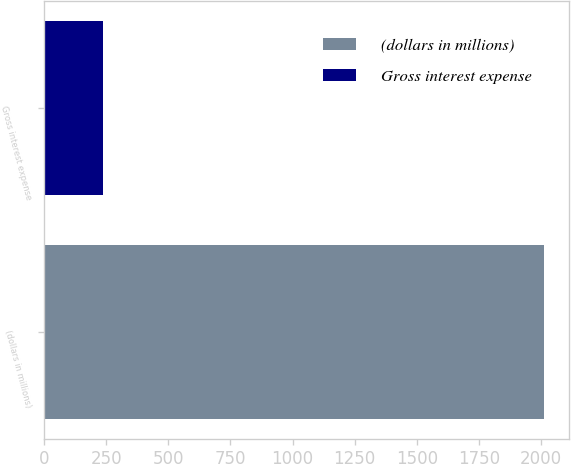Convert chart. <chart><loc_0><loc_0><loc_500><loc_500><bar_chart><fcel>(dollars in millions)<fcel>Gross interest expense<nl><fcel>2011<fcel>238<nl></chart> 